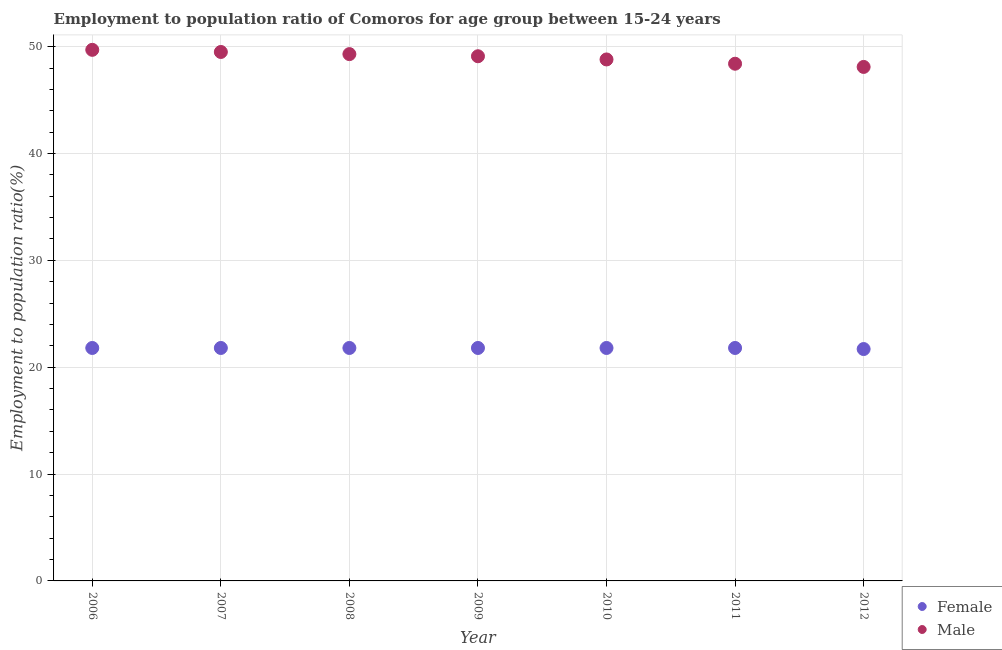How many different coloured dotlines are there?
Offer a very short reply. 2. What is the employment to population ratio(male) in 2008?
Provide a short and direct response. 49.3. Across all years, what is the maximum employment to population ratio(male)?
Your answer should be very brief. 49.7. Across all years, what is the minimum employment to population ratio(male)?
Give a very brief answer. 48.1. In which year was the employment to population ratio(male) maximum?
Provide a short and direct response. 2006. What is the total employment to population ratio(male) in the graph?
Your answer should be compact. 342.9. What is the difference between the employment to population ratio(male) in 2009 and that in 2012?
Ensure brevity in your answer.  1. What is the difference between the employment to population ratio(male) in 2011 and the employment to population ratio(female) in 2008?
Give a very brief answer. 26.6. What is the average employment to population ratio(female) per year?
Offer a very short reply. 21.79. In the year 2012, what is the difference between the employment to population ratio(male) and employment to population ratio(female)?
Ensure brevity in your answer.  26.4. In how many years, is the employment to population ratio(male) greater than 48 %?
Ensure brevity in your answer.  7. What is the difference between the highest and the second highest employment to population ratio(male)?
Your answer should be very brief. 0.2. What is the difference between the highest and the lowest employment to population ratio(female)?
Offer a terse response. 0.1. Is the sum of the employment to population ratio(female) in 2008 and 2010 greater than the maximum employment to population ratio(male) across all years?
Your response must be concise. No. Does the employment to population ratio(female) monotonically increase over the years?
Your answer should be very brief. No. Is the employment to population ratio(female) strictly greater than the employment to population ratio(male) over the years?
Provide a succinct answer. No. Is the employment to population ratio(male) strictly less than the employment to population ratio(female) over the years?
Make the answer very short. No. How many dotlines are there?
Your answer should be very brief. 2. How many years are there in the graph?
Provide a succinct answer. 7. What is the difference between two consecutive major ticks on the Y-axis?
Your response must be concise. 10. Are the values on the major ticks of Y-axis written in scientific E-notation?
Ensure brevity in your answer.  No. Does the graph contain any zero values?
Provide a succinct answer. No. Does the graph contain grids?
Ensure brevity in your answer.  Yes. How many legend labels are there?
Give a very brief answer. 2. What is the title of the graph?
Your answer should be very brief. Employment to population ratio of Comoros for age group between 15-24 years. Does "Domestic Liabilities" appear as one of the legend labels in the graph?
Ensure brevity in your answer.  No. What is the label or title of the X-axis?
Keep it short and to the point. Year. What is the label or title of the Y-axis?
Provide a short and direct response. Employment to population ratio(%). What is the Employment to population ratio(%) in Female in 2006?
Ensure brevity in your answer.  21.8. What is the Employment to population ratio(%) of Male in 2006?
Your answer should be compact. 49.7. What is the Employment to population ratio(%) of Female in 2007?
Your response must be concise. 21.8. What is the Employment to population ratio(%) in Male in 2007?
Offer a terse response. 49.5. What is the Employment to population ratio(%) of Female in 2008?
Ensure brevity in your answer.  21.8. What is the Employment to population ratio(%) in Male in 2008?
Keep it short and to the point. 49.3. What is the Employment to population ratio(%) of Female in 2009?
Ensure brevity in your answer.  21.8. What is the Employment to population ratio(%) of Male in 2009?
Provide a succinct answer. 49.1. What is the Employment to population ratio(%) in Female in 2010?
Make the answer very short. 21.8. What is the Employment to population ratio(%) in Male in 2010?
Provide a short and direct response. 48.8. What is the Employment to population ratio(%) of Female in 2011?
Give a very brief answer. 21.8. What is the Employment to population ratio(%) of Male in 2011?
Make the answer very short. 48.4. What is the Employment to population ratio(%) of Female in 2012?
Provide a succinct answer. 21.7. What is the Employment to population ratio(%) in Male in 2012?
Ensure brevity in your answer.  48.1. Across all years, what is the maximum Employment to population ratio(%) in Female?
Provide a succinct answer. 21.8. Across all years, what is the maximum Employment to population ratio(%) in Male?
Offer a very short reply. 49.7. Across all years, what is the minimum Employment to population ratio(%) in Female?
Your answer should be compact. 21.7. Across all years, what is the minimum Employment to population ratio(%) in Male?
Offer a terse response. 48.1. What is the total Employment to population ratio(%) in Female in the graph?
Your answer should be very brief. 152.5. What is the total Employment to population ratio(%) in Male in the graph?
Your answer should be very brief. 342.9. What is the difference between the Employment to population ratio(%) of Female in 2006 and that in 2007?
Offer a terse response. 0. What is the difference between the Employment to population ratio(%) in Male in 2006 and that in 2007?
Make the answer very short. 0.2. What is the difference between the Employment to population ratio(%) of Female in 2006 and that in 2008?
Provide a succinct answer. 0. What is the difference between the Employment to population ratio(%) of Female in 2006 and that in 2009?
Your answer should be compact. 0. What is the difference between the Employment to population ratio(%) of Male in 2006 and that in 2009?
Keep it short and to the point. 0.6. What is the difference between the Employment to population ratio(%) in Male in 2006 and that in 2010?
Provide a succinct answer. 0.9. What is the difference between the Employment to population ratio(%) of Female in 2006 and that in 2011?
Your answer should be compact. 0. What is the difference between the Employment to population ratio(%) in Female in 2006 and that in 2012?
Your answer should be compact. 0.1. What is the difference between the Employment to population ratio(%) of Female in 2007 and that in 2008?
Ensure brevity in your answer.  0. What is the difference between the Employment to population ratio(%) of Male in 2007 and that in 2008?
Offer a very short reply. 0.2. What is the difference between the Employment to population ratio(%) of Female in 2007 and that in 2009?
Provide a succinct answer. 0. What is the difference between the Employment to population ratio(%) of Female in 2007 and that in 2010?
Your answer should be compact. 0. What is the difference between the Employment to population ratio(%) of Female in 2007 and that in 2012?
Your answer should be very brief. 0.1. What is the difference between the Employment to population ratio(%) in Male in 2008 and that in 2009?
Your answer should be compact. 0.2. What is the difference between the Employment to population ratio(%) in Female in 2008 and that in 2010?
Make the answer very short. 0. What is the difference between the Employment to population ratio(%) of Male in 2008 and that in 2012?
Ensure brevity in your answer.  1.2. What is the difference between the Employment to population ratio(%) of Female in 2009 and that in 2010?
Your answer should be very brief. 0. What is the difference between the Employment to population ratio(%) of Male in 2009 and that in 2010?
Give a very brief answer. 0.3. What is the difference between the Employment to population ratio(%) in Female in 2009 and that in 2011?
Provide a succinct answer. 0. What is the difference between the Employment to population ratio(%) of Male in 2009 and that in 2011?
Make the answer very short. 0.7. What is the difference between the Employment to population ratio(%) of Female in 2009 and that in 2012?
Provide a short and direct response. 0.1. What is the difference between the Employment to population ratio(%) of Female in 2010 and that in 2011?
Give a very brief answer. 0. What is the difference between the Employment to population ratio(%) of Male in 2010 and that in 2012?
Offer a terse response. 0.7. What is the difference between the Employment to population ratio(%) in Female in 2011 and that in 2012?
Your response must be concise. 0.1. What is the difference between the Employment to population ratio(%) in Male in 2011 and that in 2012?
Give a very brief answer. 0.3. What is the difference between the Employment to population ratio(%) in Female in 2006 and the Employment to population ratio(%) in Male in 2007?
Your answer should be very brief. -27.7. What is the difference between the Employment to population ratio(%) in Female in 2006 and the Employment to population ratio(%) in Male in 2008?
Provide a short and direct response. -27.5. What is the difference between the Employment to population ratio(%) of Female in 2006 and the Employment to population ratio(%) of Male in 2009?
Keep it short and to the point. -27.3. What is the difference between the Employment to population ratio(%) of Female in 2006 and the Employment to population ratio(%) of Male in 2010?
Give a very brief answer. -27. What is the difference between the Employment to population ratio(%) in Female in 2006 and the Employment to population ratio(%) in Male in 2011?
Your answer should be very brief. -26.6. What is the difference between the Employment to population ratio(%) in Female in 2006 and the Employment to population ratio(%) in Male in 2012?
Ensure brevity in your answer.  -26.3. What is the difference between the Employment to population ratio(%) in Female in 2007 and the Employment to population ratio(%) in Male in 2008?
Give a very brief answer. -27.5. What is the difference between the Employment to population ratio(%) of Female in 2007 and the Employment to population ratio(%) of Male in 2009?
Provide a short and direct response. -27.3. What is the difference between the Employment to population ratio(%) of Female in 2007 and the Employment to population ratio(%) of Male in 2011?
Keep it short and to the point. -26.6. What is the difference between the Employment to population ratio(%) of Female in 2007 and the Employment to population ratio(%) of Male in 2012?
Offer a very short reply. -26.3. What is the difference between the Employment to population ratio(%) of Female in 2008 and the Employment to population ratio(%) of Male in 2009?
Offer a terse response. -27.3. What is the difference between the Employment to population ratio(%) of Female in 2008 and the Employment to population ratio(%) of Male in 2010?
Ensure brevity in your answer.  -27. What is the difference between the Employment to population ratio(%) of Female in 2008 and the Employment to population ratio(%) of Male in 2011?
Keep it short and to the point. -26.6. What is the difference between the Employment to population ratio(%) in Female in 2008 and the Employment to population ratio(%) in Male in 2012?
Provide a short and direct response. -26.3. What is the difference between the Employment to population ratio(%) in Female in 2009 and the Employment to population ratio(%) in Male in 2011?
Provide a succinct answer. -26.6. What is the difference between the Employment to population ratio(%) of Female in 2009 and the Employment to population ratio(%) of Male in 2012?
Give a very brief answer. -26.3. What is the difference between the Employment to population ratio(%) of Female in 2010 and the Employment to population ratio(%) of Male in 2011?
Your answer should be very brief. -26.6. What is the difference between the Employment to population ratio(%) of Female in 2010 and the Employment to population ratio(%) of Male in 2012?
Ensure brevity in your answer.  -26.3. What is the difference between the Employment to population ratio(%) in Female in 2011 and the Employment to population ratio(%) in Male in 2012?
Keep it short and to the point. -26.3. What is the average Employment to population ratio(%) of Female per year?
Offer a terse response. 21.79. What is the average Employment to population ratio(%) of Male per year?
Give a very brief answer. 48.99. In the year 2006, what is the difference between the Employment to population ratio(%) in Female and Employment to population ratio(%) in Male?
Your answer should be compact. -27.9. In the year 2007, what is the difference between the Employment to population ratio(%) in Female and Employment to population ratio(%) in Male?
Provide a short and direct response. -27.7. In the year 2008, what is the difference between the Employment to population ratio(%) of Female and Employment to population ratio(%) of Male?
Provide a short and direct response. -27.5. In the year 2009, what is the difference between the Employment to population ratio(%) in Female and Employment to population ratio(%) in Male?
Ensure brevity in your answer.  -27.3. In the year 2011, what is the difference between the Employment to population ratio(%) of Female and Employment to population ratio(%) of Male?
Keep it short and to the point. -26.6. In the year 2012, what is the difference between the Employment to population ratio(%) in Female and Employment to population ratio(%) in Male?
Provide a succinct answer. -26.4. What is the ratio of the Employment to population ratio(%) of Female in 2006 to that in 2008?
Offer a terse response. 1. What is the ratio of the Employment to population ratio(%) in Male in 2006 to that in 2008?
Keep it short and to the point. 1.01. What is the ratio of the Employment to population ratio(%) in Male in 2006 to that in 2009?
Provide a succinct answer. 1.01. What is the ratio of the Employment to population ratio(%) of Male in 2006 to that in 2010?
Ensure brevity in your answer.  1.02. What is the ratio of the Employment to population ratio(%) in Male in 2006 to that in 2011?
Offer a terse response. 1.03. What is the ratio of the Employment to population ratio(%) of Male in 2006 to that in 2012?
Your answer should be very brief. 1.03. What is the ratio of the Employment to population ratio(%) in Female in 2007 to that in 2009?
Provide a short and direct response. 1. What is the ratio of the Employment to population ratio(%) in Male in 2007 to that in 2009?
Ensure brevity in your answer.  1.01. What is the ratio of the Employment to population ratio(%) in Female in 2007 to that in 2010?
Make the answer very short. 1. What is the ratio of the Employment to population ratio(%) in Male in 2007 to that in 2010?
Offer a terse response. 1.01. What is the ratio of the Employment to population ratio(%) in Male in 2007 to that in 2011?
Your response must be concise. 1.02. What is the ratio of the Employment to population ratio(%) of Male in 2007 to that in 2012?
Provide a succinct answer. 1.03. What is the ratio of the Employment to population ratio(%) in Male in 2008 to that in 2010?
Ensure brevity in your answer.  1.01. What is the ratio of the Employment to population ratio(%) in Male in 2008 to that in 2011?
Keep it short and to the point. 1.02. What is the ratio of the Employment to population ratio(%) of Female in 2008 to that in 2012?
Give a very brief answer. 1. What is the ratio of the Employment to population ratio(%) in Male in 2008 to that in 2012?
Provide a short and direct response. 1.02. What is the ratio of the Employment to population ratio(%) of Female in 2009 to that in 2010?
Offer a terse response. 1. What is the ratio of the Employment to population ratio(%) in Male in 2009 to that in 2010?
Offer a terse response. 1.01. What is the ratio of the Employment to population ratio(%) of Male in 2009 to that in 2011?
Your response must be concise. 1.01. What is the ratio of the Employment to population ratio(%) in Female in 2009 to that in 2012?
Your answer should be compact. 1. What is the ratio of the Employment to population ratio(%) of Male in 2009 to that in 2012?
Your answer should be compact. 1.02. What is the ratio of the Employment to population ratio(%) in Male in 2010 to that in 2011?
Keep it short and to the point. 1.01. What is the ratio of the Employment to population ratio(%) in Female in 2010 to that in 2012?
Keep it short and to the point. 1. What is the ratio of the Employment to population ratio(%) in Male in 2010 to that in 2012?
Your answer should be compact. 1.01. What is the ratio of the Employment to population ratio(%) in Female in 2011 to that in 2012?
Your answer should be compact. 1. What is the ratio of the Employment to population ratio(%) of Male in 2011 to that in 2012?
Offer a very short reply. 1.01. What is the difference between the highest and the second highest Employment to population ratio(%) of Female?
Offer a terse response. 0. What is the difference between the highest and the lowest Employment to population ratio(%) in Male?
Offer a terse response. 1.6. 